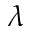<formula> <loc_0><loc_0><loc_500><loc_500>\lambda</formula> 